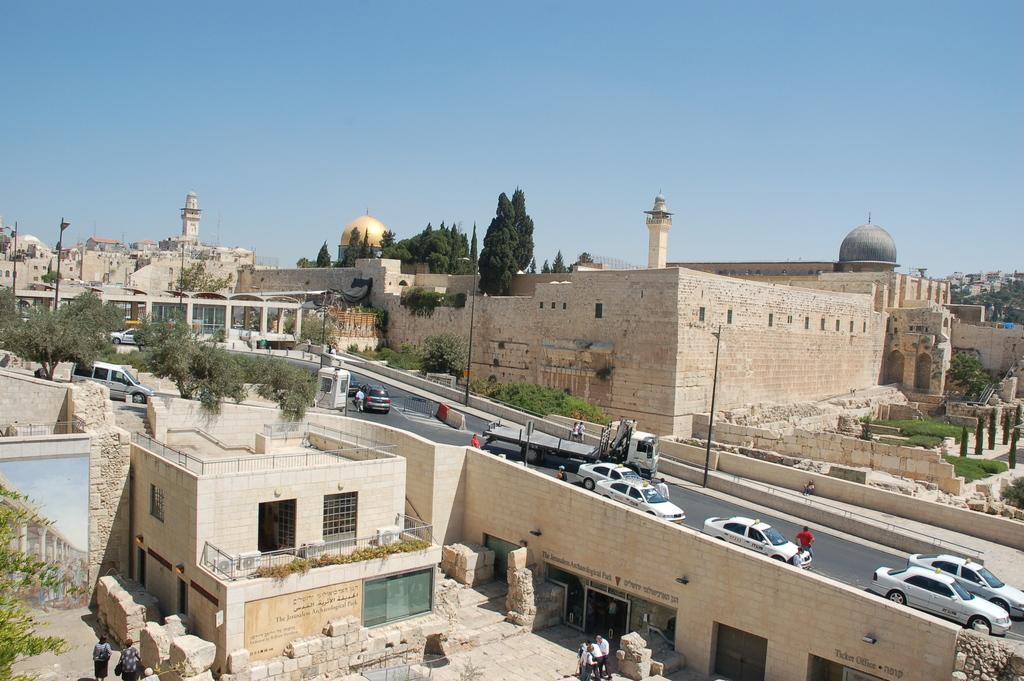Could you give a brief overview of what you see in this image? In this image we can see buildings, trees, road, bridge, cars, poles and sky. 